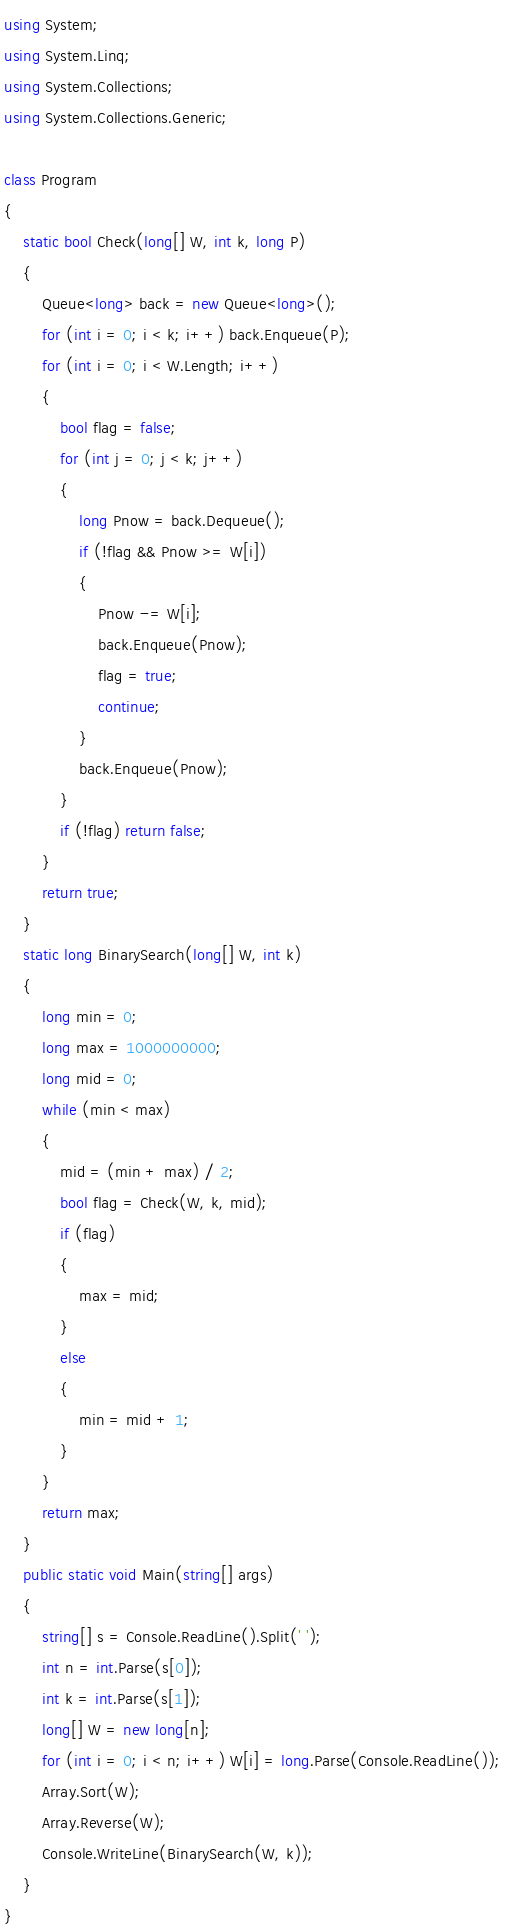<code> <loc_0><loc_0><loc_500><loc_500><_C#_>using System;
using System.Linq;
using System.Collections;
using System.Collections.Generic;

class Program
{
    static bool Check(long[] W, int k, long P)
    {
        Queue<long> back = new Queue<long>();
        for (int i = 0; i < k; i++) back.Enqueue(P);
        for (int i = 0; i < W.Length; i++)
        {
            bool flag = false;
            for (int j = 0; j < k; j++)
            {
                long Pnow = back.Dequeue();
                if (!flag && Pnow >= W[i])
                {
                    Pnow -= W[i];
                    back.Enqueue(Pnow);
                    flag = true;
                    continue;
                }
                back.Enqueue(Pnow);
            }
            if (!flag) return false;
        }
        return true;
    }
    static long BinarySearch(long[] W, int k)
    {
        long min = 0;
        long max = 1000000000;
        long mid = 0;
        while (min < max)
        {
            mid = (min + max) / 2;
            bool flag = Check(W, k, mid);
            if (flag)
            {
                max = mid;
            }
            else
            {
                min = mid + 1;
            }
        }
        return max;
    }
    public static void Main(string[] args)
    {
        string[] s = Console.ReadLine().Split(' ');
        int n = int.Parse(s[0]);
        int k = int.Parse(s[1]);
        long[] W = new long[n];
        for (int i = 0; i < n; i++) W[i] = long.Parse(Console.ReadLine());
        Array.Sort(W);
        Array.Reverse(W);
        Console.WriteLine(BinarySearch(W, k));
    }
}
</code> 